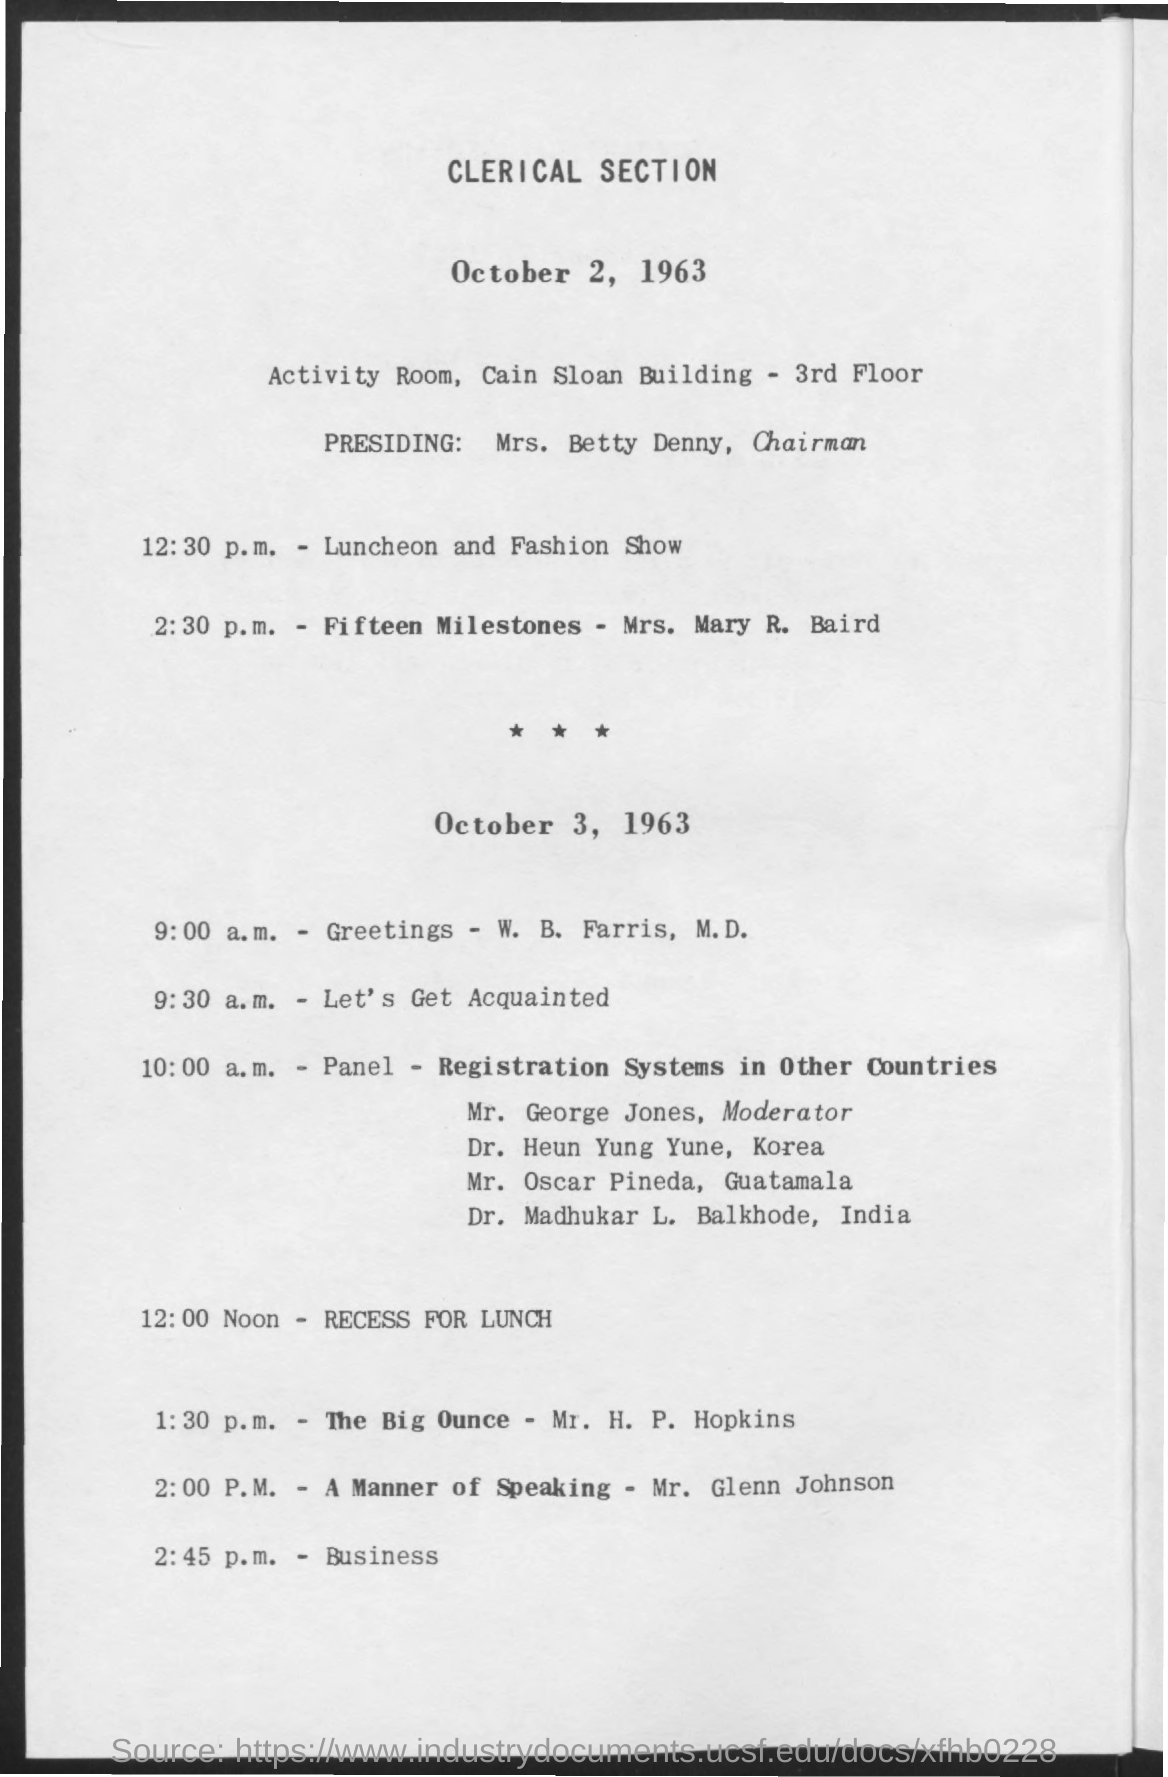List a handful of essential elements in this visual. The first title in the document is 'Clerical Section.' 